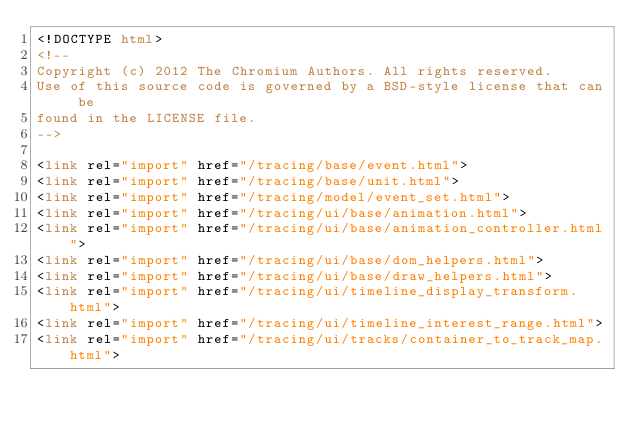Convert code to text. <code><loc_0><loc_0><loc_500><loc_500><_HTML_><!DOCTYPE html>
<!--
Copyright (c) 2012 The Chromium Authors. All rights reserved.
Use of this source code is governed by a BSD-style license that can be
found in the LICENSE file.
-->

<link rel="import" href="/tracing/base/event.html">
<link rel="import" href="/tracing/base/unit.html">
<link rel="import" href="/tracing/model/event_set.html">
<link rel="import" href="/tracing/ui/base/animation.html">
<link rel="import" href="/tracing/ui/base/animation_controller.html">
<link rel="import" href="/tracing/ui/base/dom_helpers.html">
<link rel="import" href="/tracing/ui/base/draw_helpers.html">
<link rel="import" href="/tracing/ui/timeline_display_transform.html">
<link rel="import" href="/tracing/ui/timeline_interest_range.html">
<link rel="import" href="/tracing/ui/tracks/container_to_track_map.html"></code> 